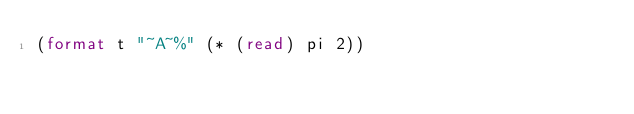Convert code to text. <code><loc_0><loc_0><loc_500><loc_500><_Lisp_>(format t "~A~%" (* (read) pi 2))</code> 